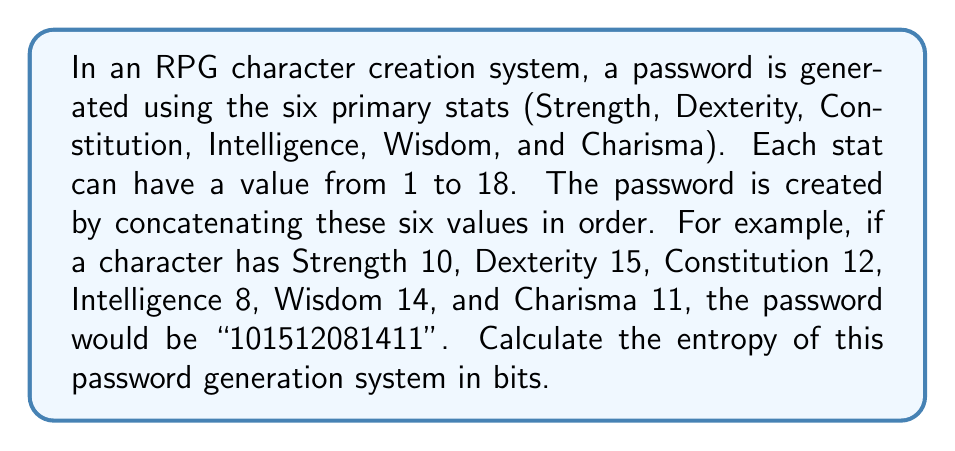Can you answer this question? Let's approach this step-by-step:

1) First, we need to understand what entropy is. In cryptography, entropy is a measure of the unpredictability of a password. It's calculated using the formula:

   $$ H = \log_2(N) $$

   where $H$ is the entropy in bits, and $N$ is the number of possible passwords.

2) In this system, each stat can have 18 possible values (1 to 18).

3) We have 6 stats in total, and each stat's value is independent of the others.

4) Therefore, the total number of possible passwords is:

   $$ N = 18^6 $$

   This is because for each of the 6 positions, we have 18 choices.

5) Now we can plug this into our entropy formula:

   $$ H = \log_2(18^6) $$

6) Using the logarithm rule $\log_a(x^n) = n\log_a(x)$, we can simplify:

   $$ H = 6 \log_2(18) $$

7) Using a calculator or computer, we can evaluate this:

   $$ H \approx 6 * 4.17 \approx 25.02 $$

Thus, the entropy of this password generation system is approximately 25.02 bits.
Answer: 25.02 bits 